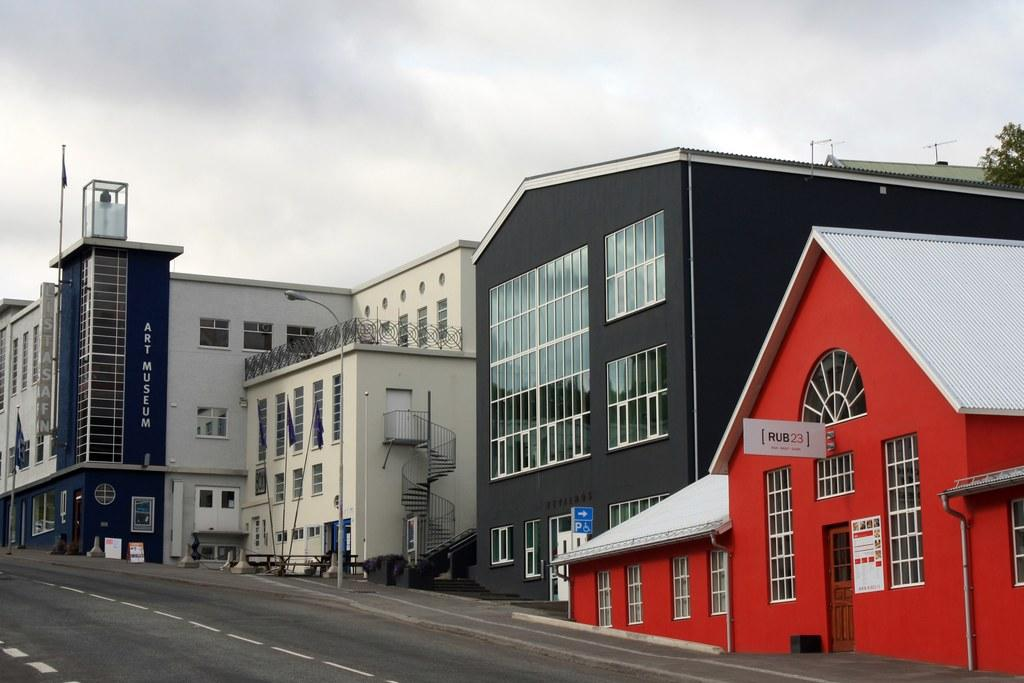What type of structures are present in the image? There are buildings in the image. What features can be seen on the buildings? The buildings have windows and doors. What is located at the bottom of the image? There is a road at the bottom of the image. What is visible in the sky at the top of the image? There are clouds in the sky at the top of the image. What type of vegetation is on the right side of the image? There is a plant on the right side of the image. What type of substance is being thought about by the pie in the image? There is no pie present in the image, and therefore no such thought process can be observed. 